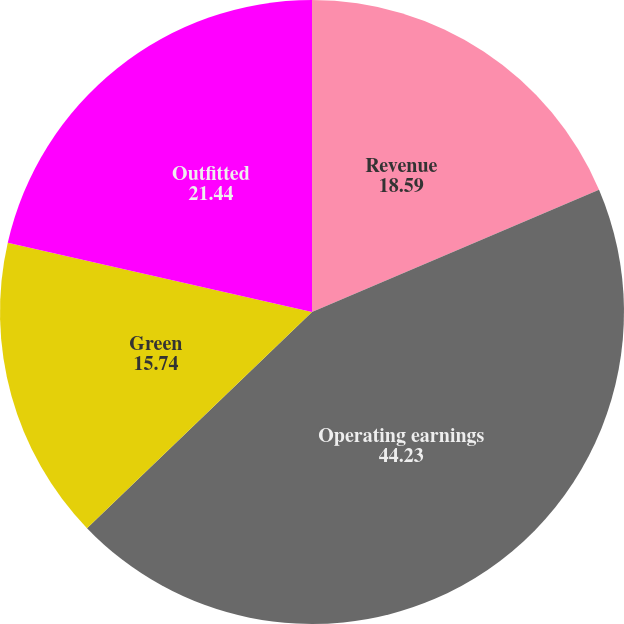Convert chart to OTSL. <chart><loc_0><loc_0><loc_500><loc_500><pie_chart><fcel>Revenue<fcel>Operating earnings<fcel>Green<fcel>Outfitted<nl><fcel>18.59%<fcel>44.23%<fcel>15.74%<fcel>21.44%<nl></chart> 